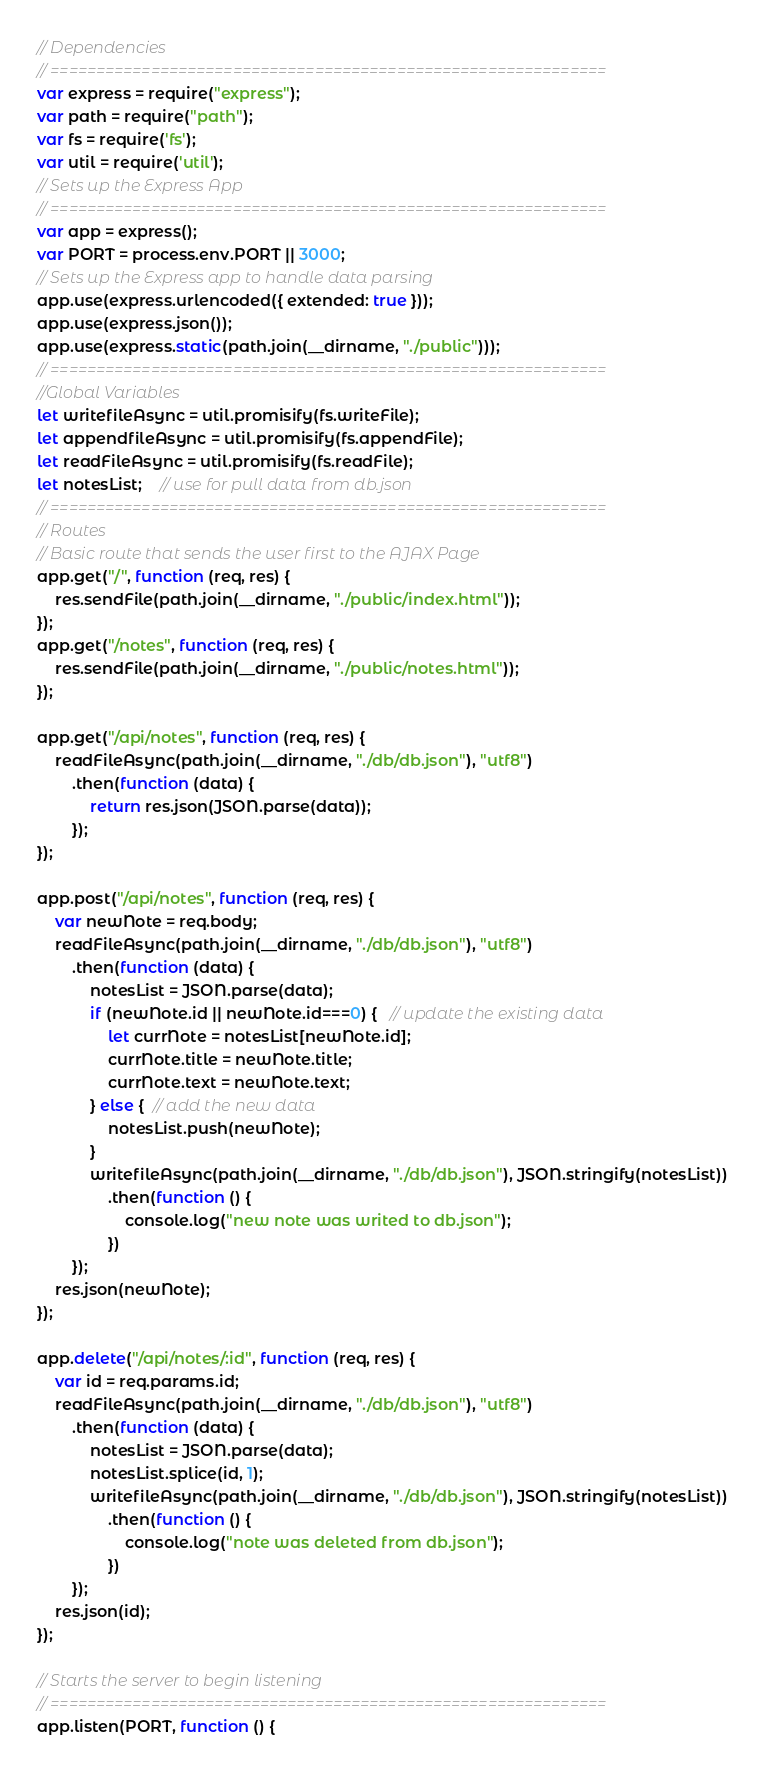<code> <loc_0><loc_0><loc_500><loc_500><_JavaScript_>// Dependencies
// =============================================================
var express = require("express");
var path = require("path");
var fs = require('fs');
var util = require('util');
// Sets up the Express App
// =============================================================
var app = express();
var PORT = process.env.PORT || 3000;
// Sets up the Express app to handle data parsing
app.use(express.urlencoded({ extended: true }));
app.use(express.json());
app.use(express.static(path.join(__dirname, "./public")));
// =============================================================
//Global Variables
let writefileAsync = util.promisify(fs.writeFile);
let appendfileAsync = util.promisify(fs.appendFile);
let readFileAsync = util.promisify(fs.readFile);
let notesList;    // use for pull data from db.json
// =============================================================
// Routes
// Basic route that sends the user first to the AJAX Page
app.get("/", function (req, res) {
    res.sendFile(path.join(__dirname, "./public/index.html"));
});
app.get("/notes", function (req, res) {
    res.sendFile(path.join(__dirname, "./public/notes.html"));
});

app.get("/api/notes", function (req, res) {
    readFileAsync(path.join(__dirname, "./db/db.json"), "utf8")
        .then(function (data) {
            return res.json(JSON.parse(data));
        });
});

app.post("/api/notes", function (req, res) {
    var newNote = req.body;
    readFileAsync(path.join(__dirname, "./db/db.json"), "utf8")
        .then(function (data) {
            notesList = JSON.parse(data);
            if (newNote.id || newNote.id===0) {   // update the existing data
                let currNote = notesList[newNote.id];
                currNote.title = newNote.title;
                currNote.text = newNote.text;
            } else {  // add the new data
                notesList.push(newNote);
            }
            writefileAsync(path.join(__dirname, "./db/db.json"), JSON.stringify(notesList))
                .then(function () {
                    console.log("new note was writed to db.json");
                })
        });
    res.json(newNote);
});

app.delete("/api/notes/:id", function (req, res) {
    var id = req.params.id;
    readFileAsync(path.join(__dirname, "./db/db.json"), "utf8")
        .then(function (data) {
            notesList = JSON.parse(data);
            notesList.splice(id, 1);
            writefileAsync(path.join(__dirname, "./db/db.json"), JSON.stringify(notesList))
                .then(function () {
                    console.log("note was deleted from db.json");
                })
        });
    res.json(id);
});

// Starts the server to begin listening
// =============================================================
app.listen(PORT, function () {</code> 